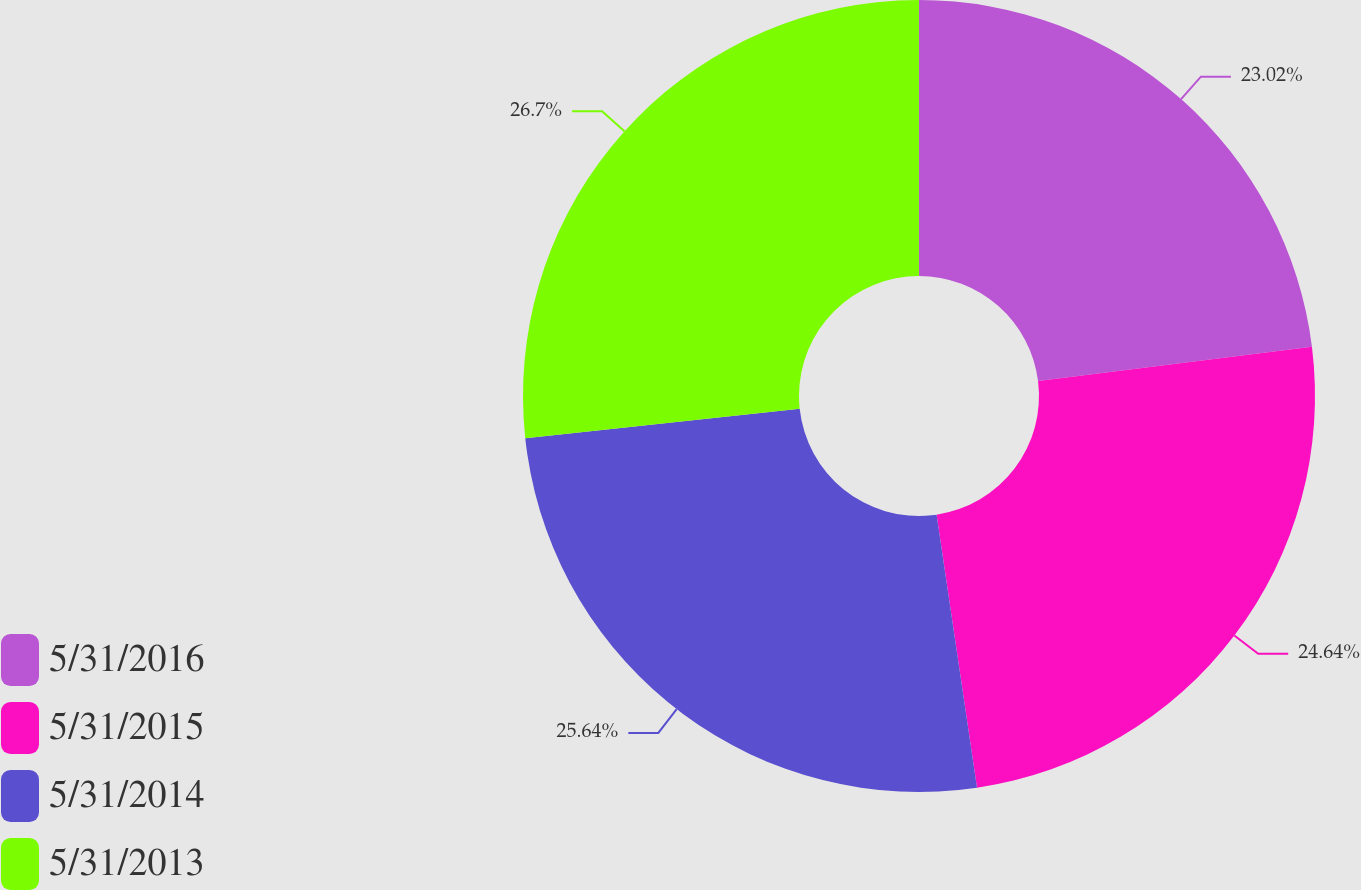Convert chart. <chart><loc_0><loc_0><loc_500><loc_500><pie_chart><fcel>5/31/2016<fcel>5/31/2015<fcel>5/31/2014<fcel>5/31/2013<nl><fcel>23.02%<fcel>24.64%<fcel>25.64%<fcel>26.7%<nl></chart> 